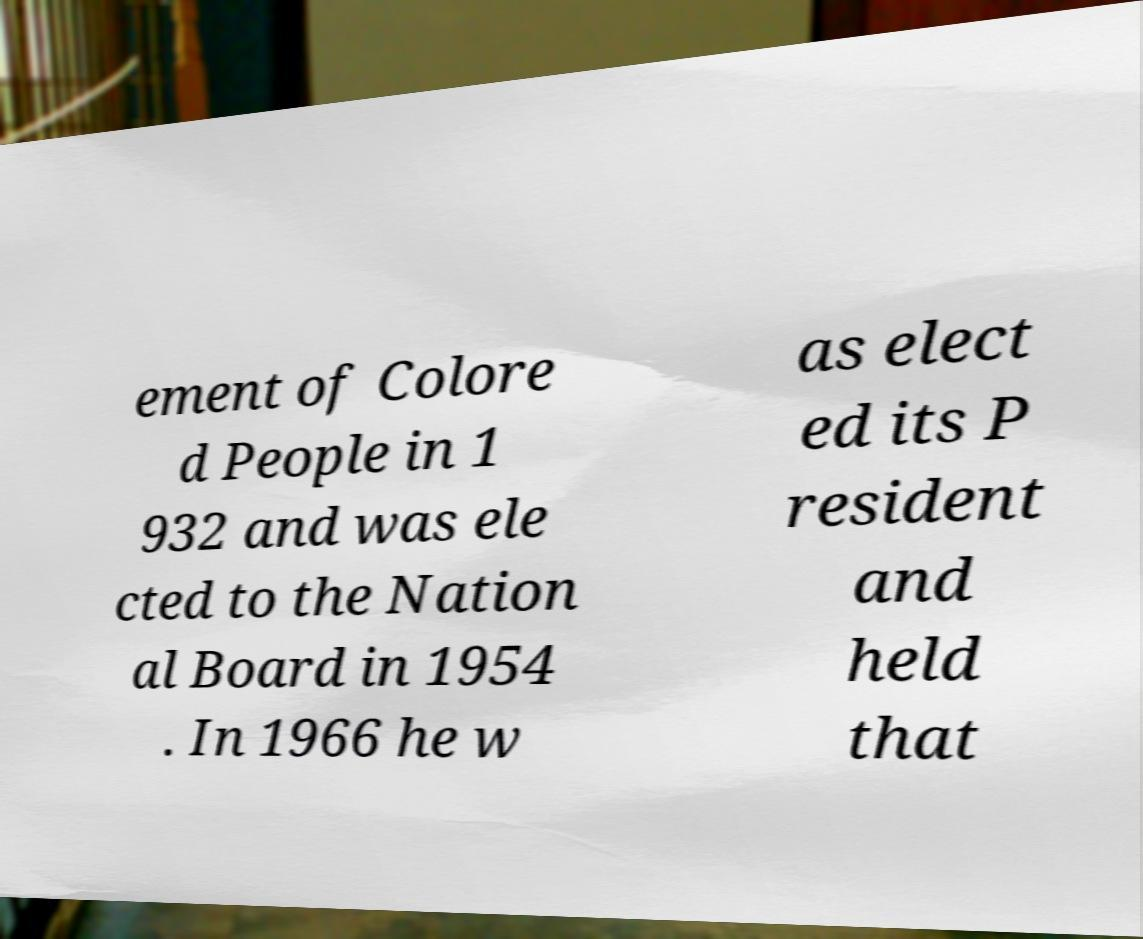Could you extract and type out the text from this image? ement of Colore d People in 1 932 and was ele cted to the Nation al Board in 1954 . In 1966 he w as elect ed its P resident and held that 